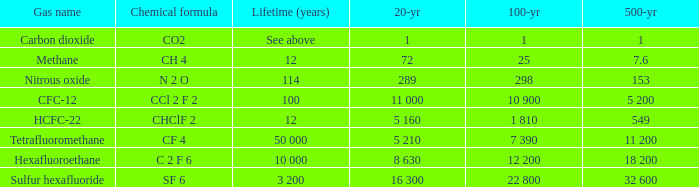What is the 100-year period when 500-year period is 153? 298.0. 